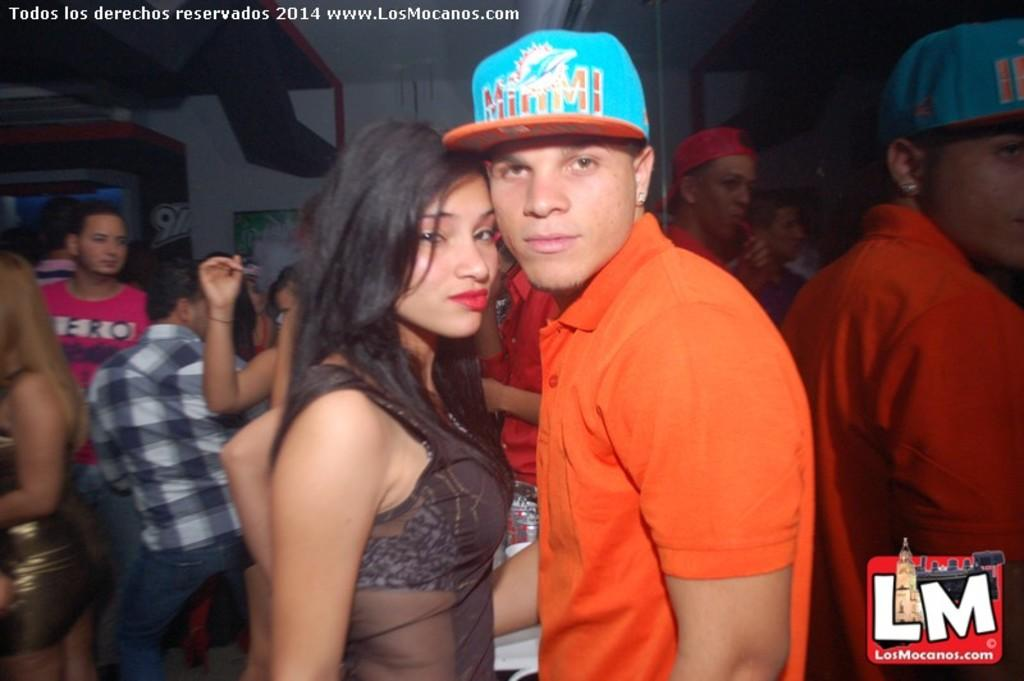<image>
Share a concise interpretation of the image provided. Man and Woman that are together posing for a photo, the man has a Miami Dolphins cap. 